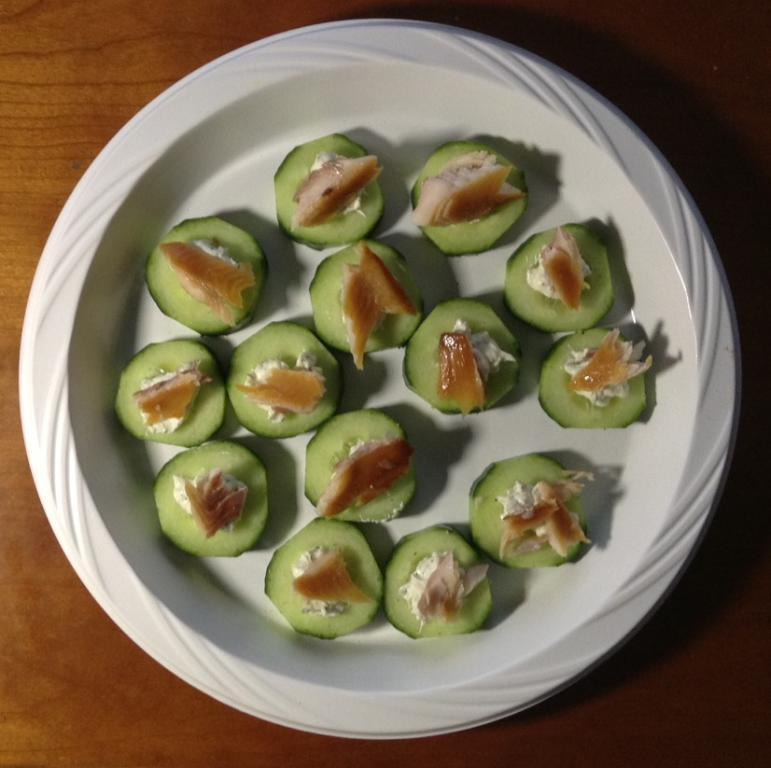What object is in the center of the image? There is a plate in the center of the image. What is on the plate? There is food on the plate. Can you describe the positioning of the plate in the image? The plate is in the center of the image. What type of record can be seen spinning on the plate in the image? There is no record present in the image; it features a plate with food on it. What kind of trick is being performed with the plate in the image? There is no trick being performed with the plate in the image; it is simply a plate with food on it. 